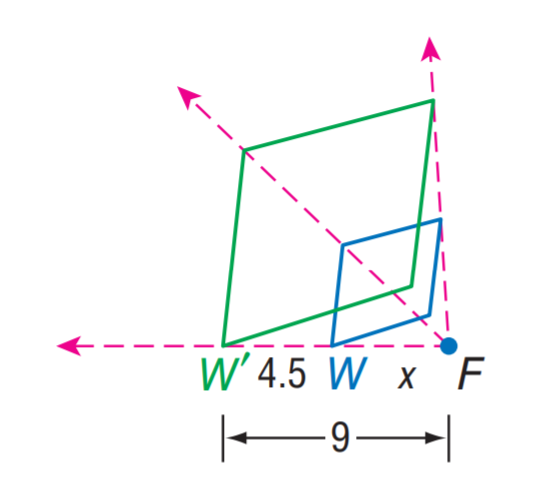Answer the mathemtical geometry problem and directly provide the correct option letter.
Question: Find the scale factor from W to W'.
Choices: A: 2 B: 4.5 C: 9 D: 18 A 